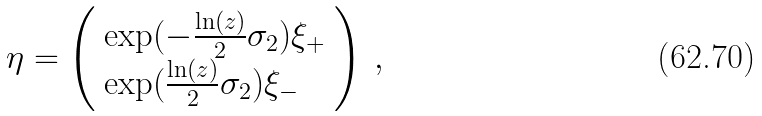<formula> <loc_0><loc_0><loc_500><loc_500>\eta = \left ( \begin{array} { l } { { \exp ( - \frac { \ln ( z ) } { 2 } \sigma _ { 2 } ) \xi _ { + } } } \\ { { \exp ( \frac { \ln ( z ) } { 2 } \sigma _ { 2 } ) \xi _ { - } } } \end{array} \right ) \, ,</formula> 